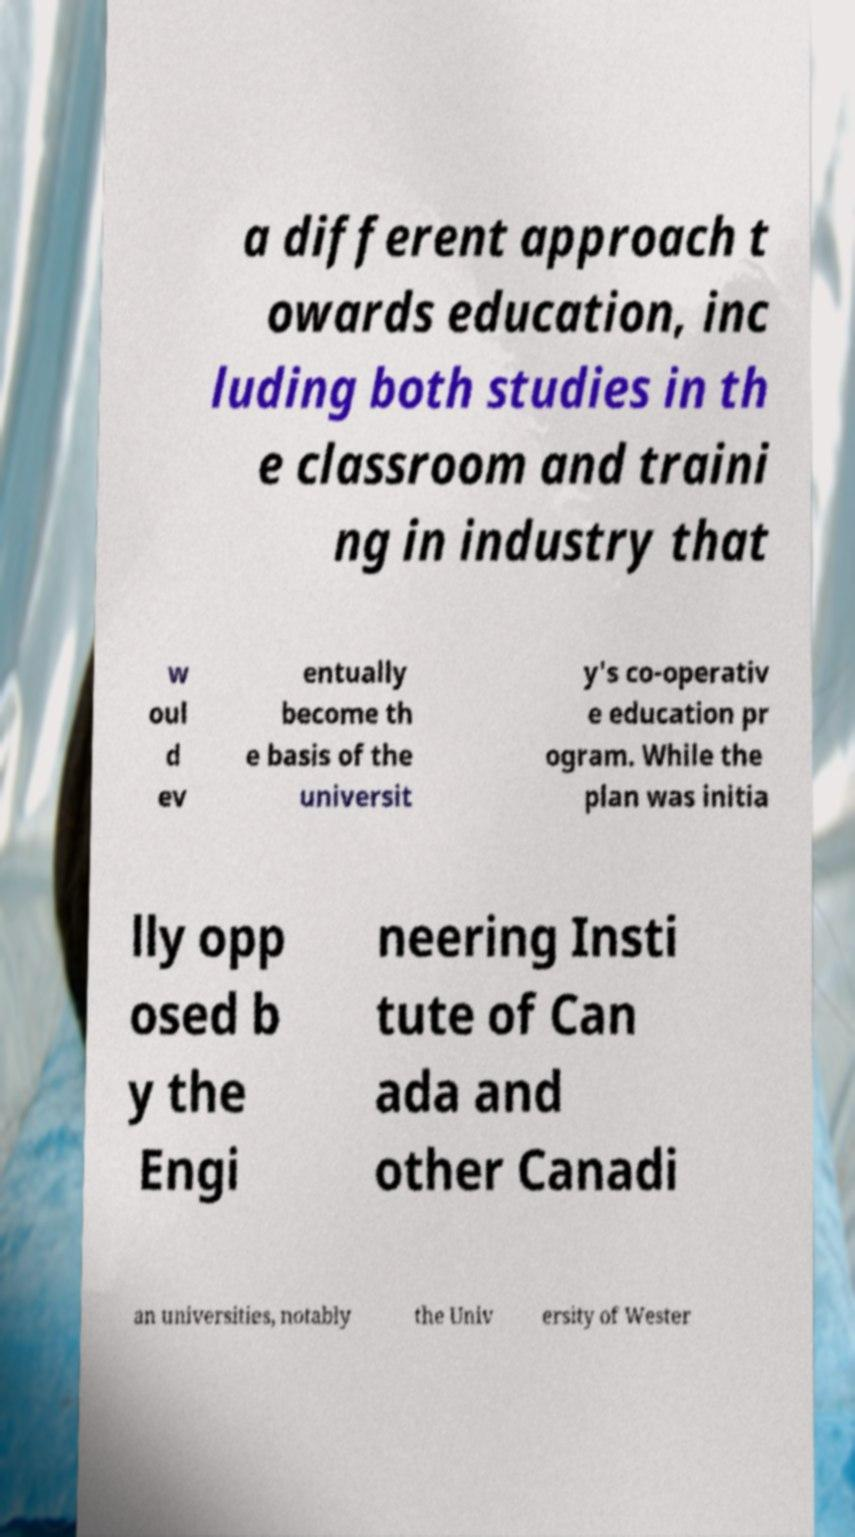Could you extract and type out the text from this image? a different approach t owards education, inc luding both studies in th e classroom and traini ng in industry that w oul d ev entually become th e basis of the universit y's co-operativ e education pr ogram. While the plan was initia lly opp osed b y the Engi neering Insti tute of Can ada and other Canadi an universities, notably the Univ ersity of Wester 